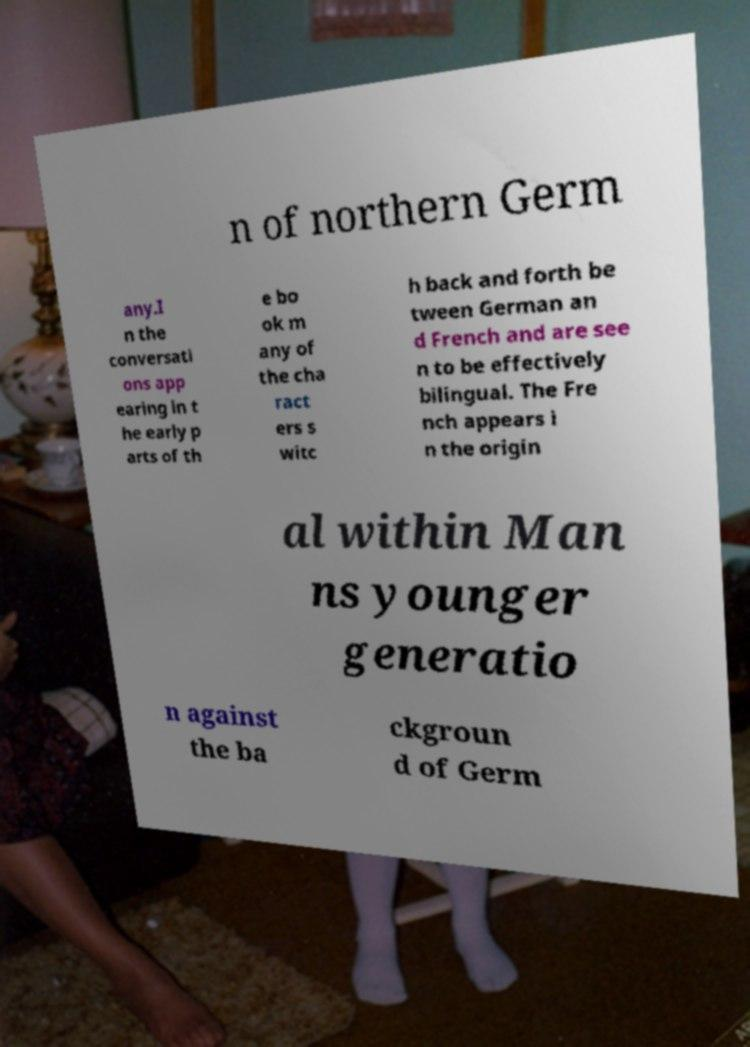Can you accurately transcribe the text from the provided image for me? n of northern Germ any.I n the conversati ons app earing in t he early p arts of th e bo ok m any of the cha ract ers s witc h back and forth be tween German an d French and are see n to be effectively bilingual. The Fre nch appears i n the origin al within Man ns younger generatio n against the ba ckgroun d of Germ 